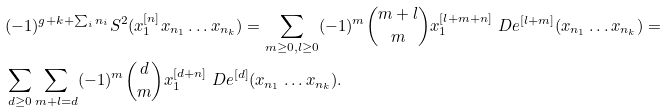<formula> <loc_0><loc_0><loc_500><loc_500>& ( - 1 ) ^ { g + k + \sum _ { i } n _ { i } } S ^ { 2 } ( x _ { 1 } ^ { [ n ] } x _ { n _ { 1 } } \dots x _ { n _ { k } } ) = \sum _ { m \geq 0 , l \geq 0 } ( - 1 ) ^ { m } { m + l \choose m } x _ { 1 } ^ { [ l + m + n ] } \ D e ^ { [ l + m ] } ( x _ { n _ { 1 } } \dots x _ { n _ { k } } ) = \\ & \sum _ { d \geq 0 } \sum _ { m + l = d } ( - 1 ) ^ { m } { d \choose m } x _ { 1 } ^ { [ d + n ] } \ D e ^ { [ d ] } ( x _ { n _ { 1 } } \dots x _ { n _ { k } } ) .</formula> 